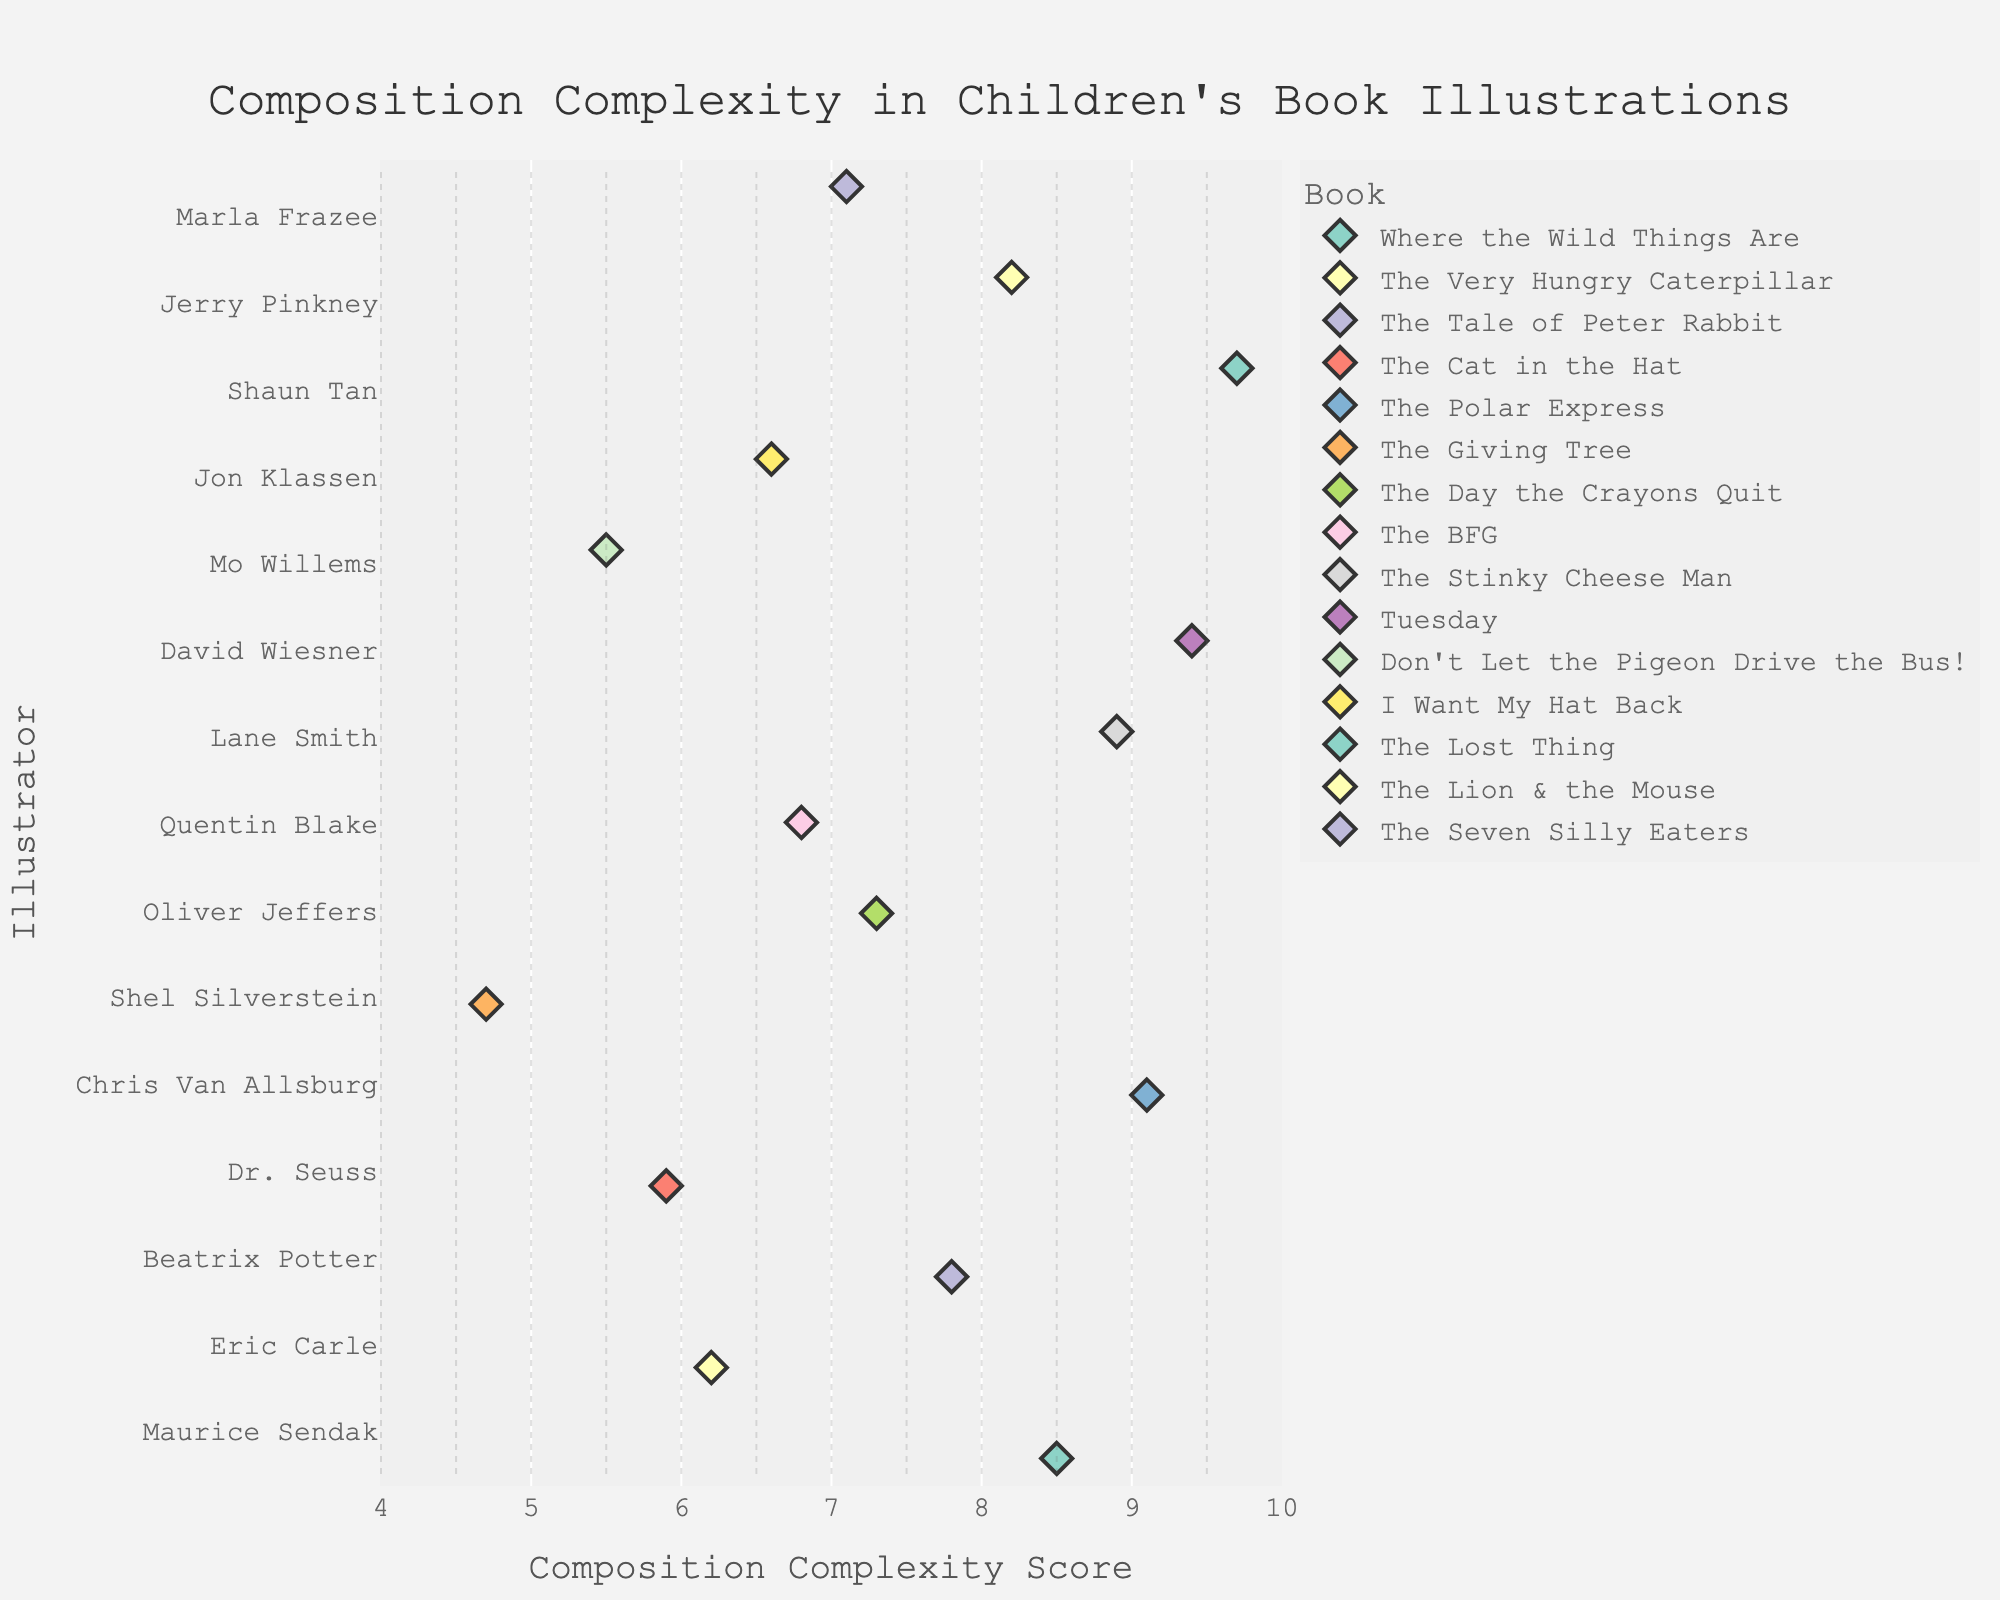Which illustrator has the highest composition complexity score? The vertical axis (y-axis) shows the illustrators, and the horizontal axis (x-axis) displays the composition complexity scores. The data point with the highest score is farthest to the right.
Answer: Shaun Tan What is the range of composition complexity scores in the dataset? To determine the range, find the difference between the highest and lowest scores. The highest score is 9.7 (Shaun Tan), and the lowest score is 4.7 (Shel Silverstein).
Answer: 5.0 How many illustrators have a composition complexity score above 8.0? Identify the illustrators with points to the right of the 8.0 mark on the x-axis. Count these points.
Answer: 6 illustrators Which two books have composition complexity scores closest to each other? Look for the points that are closest to each other on the x-axis. "The Tale of Peter Rabbit" (7.8) and "The Day the Crayons Quit" (7.3) are close.
Answer: The Tale of Peter Rabbit & The Day the Crayons Quit What is the median composition complexity score? List all the composition complexity scores in ascending order and identify the middle value. The scores are 4.7, 5.5, 5.9, 6.2, 6.6, 6.8, 7.1, 7.3, 7.8, 8.2, 8.5, 8.9, 9.1, 9.4, 9.7. The median is the 8th score.
Answer: 7.3 Are there any illustrators with the same composition complexity score? Check for overlapping or identical points on the plot. None of the points overlap, so there are no identical scores.
Answer: No Which book by Chris Van Allsburg has the composition complexity score? On the color legend, identify the color representing Chris Van Allsburg's book and match it to the corresponding point.
Answer: The Polar Express Compare the composition complexity scores of Maurice Sendak and Jerry Pinkney. Find the points for Maurice Sendak and Jerry Pinkney. Maurice Sendak (8.5) and Jerry Pinkney (8.2). Compare these two values.
Answer: Maurice Sendak has a higher score than Jerry Pinkney 